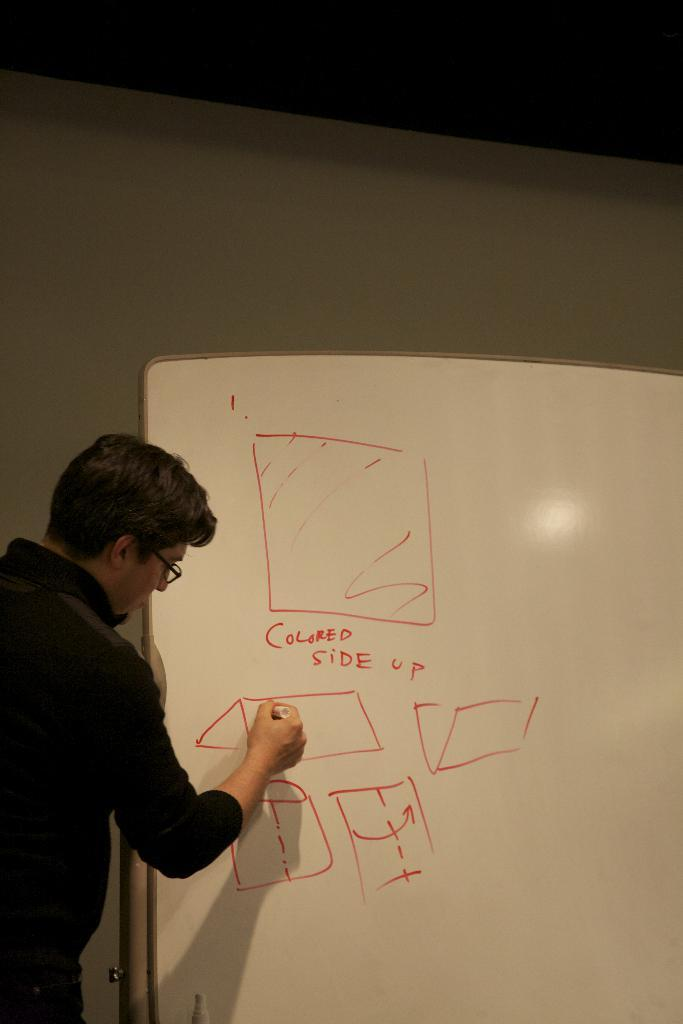<image>
Give a short and clear explanation of the subsequent image. A man has written "colored side up" on a whiteboard with several shapes 